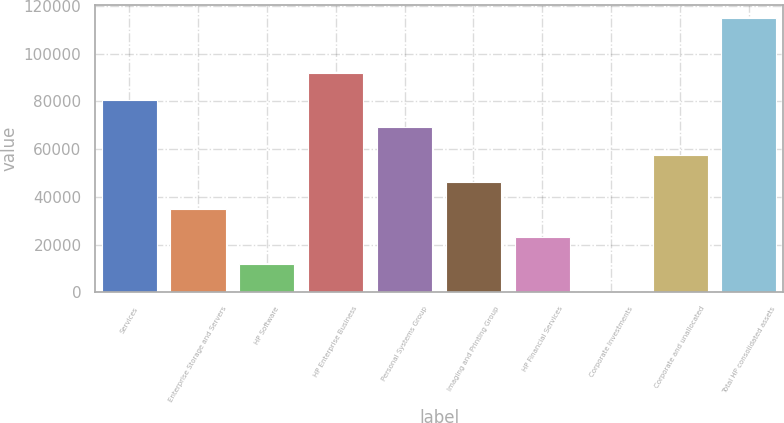Convert chart. <chart><loc_0><loc_0><loc_500><loc_500><bar_chart><fcel>Services<fcel>Enterprise Storage and Servers<fcel>HP Software<fcel>HP Enterprise Business<fcel>Personal Systems Group<fcel>Imaging and Printing Group<fcel>HP Financial Services<fcel>Corporate Investments<fcel>Corporate and unallocated<fcel>Total HP consolidated assets<nl><fcel>80497.3<fcel>34761.7<fcel>11893.9<fcel>91931.2<fcel>69063.4<fcel>46195.6<fcel>23327.8<fcel>460<fcel>57629.5<fcel>114799<nl></chart> 